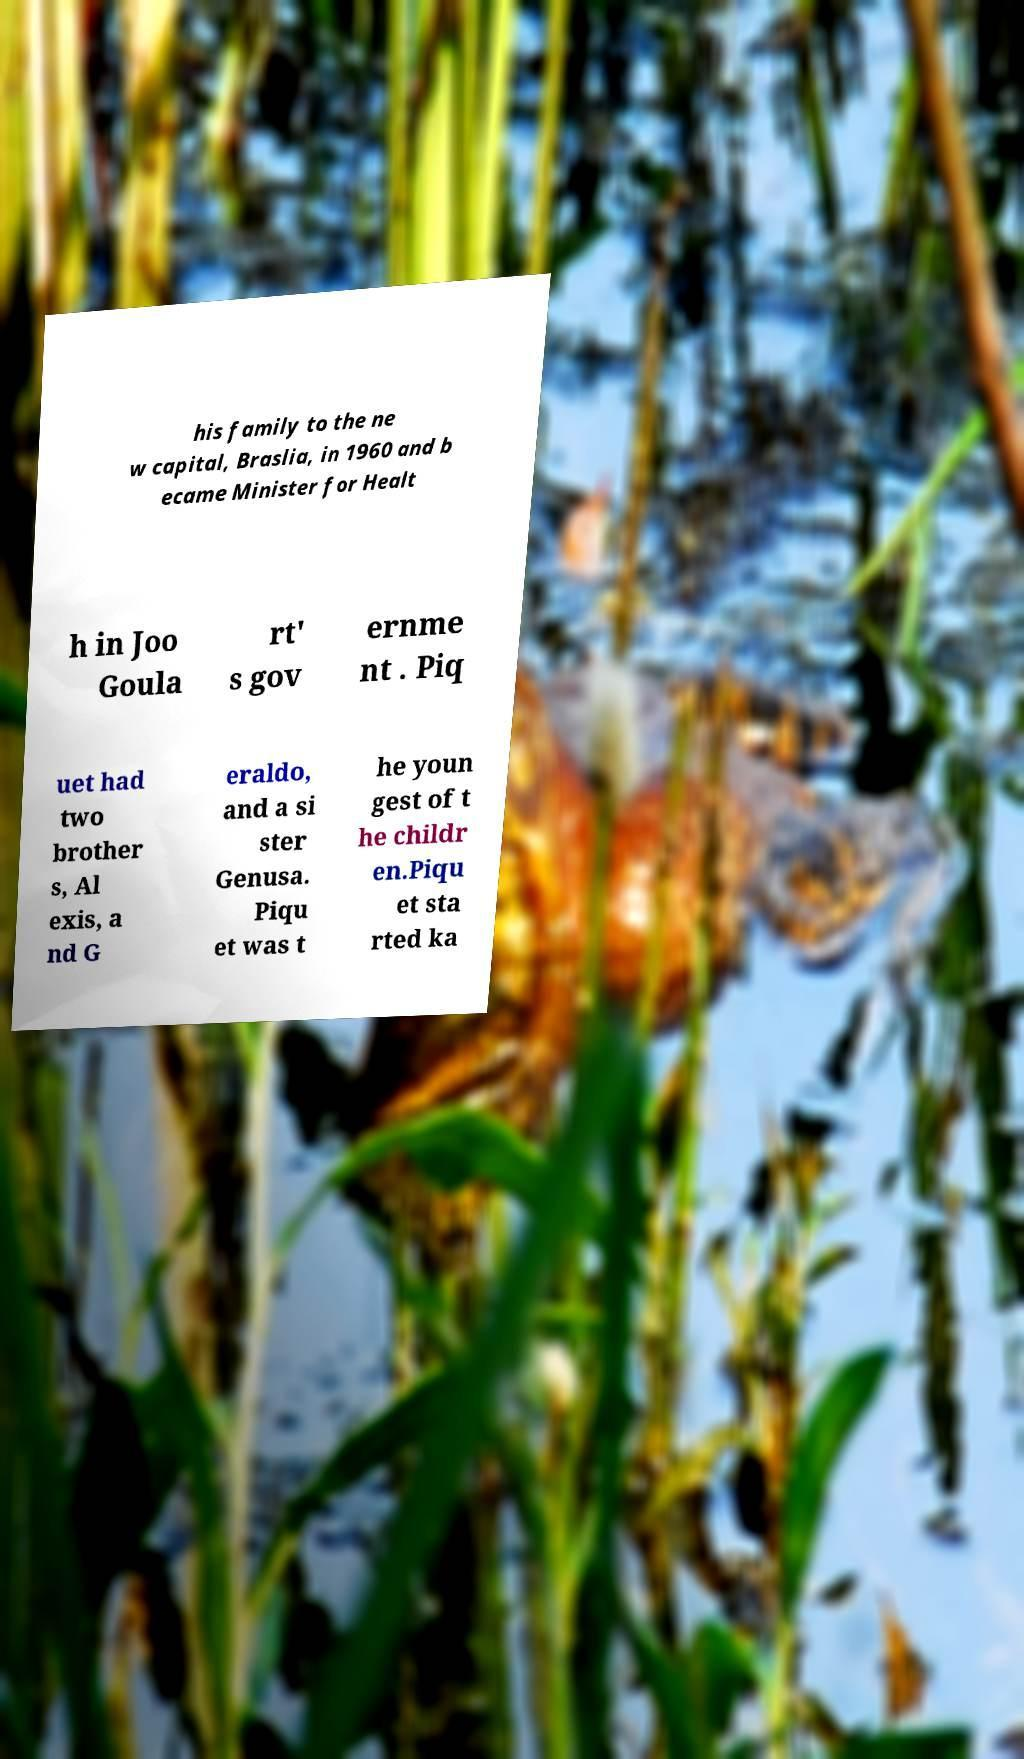Can you read and provide the text displayed in the image?This photo seems to have some interesting text. Can you extract and type it out for me? his family to the ne w capital, Braslia, in 1960 and b ecame Minister for Healt h in Joo Goula rt' s gov ernme nt . Piq uet had two brother s, Al exis, a nd G eraldo, and a si ster Genusa. Piqu et was t he youn gest of t he childr en.Piqu et sta rted ka 